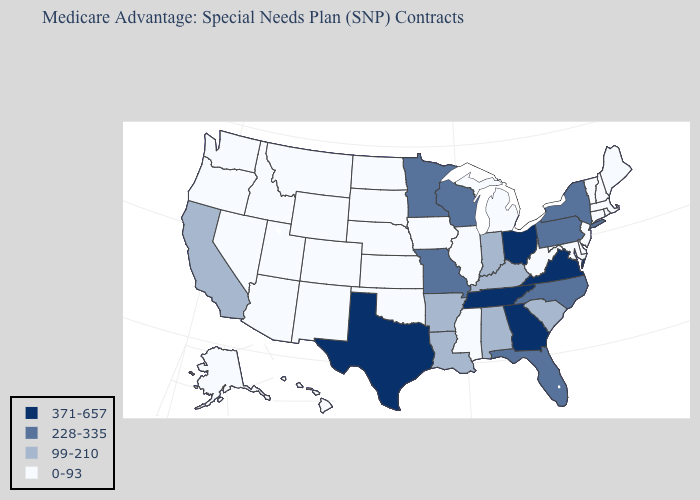Name the states that have a value in the range 0-93?
Write a very short answer. Alaska, Arizona, Colorado, Connecticut, Delaware, Hawaii, Iowa, Idaho, Illinois, Kansas, Massachusetts, Maryland, Maine, Michigan, Mississippi, Montana, North Dakota, Nebraska, New Hampshire, New Jersey, New Mexico, Nevada, Oklahoma, Oregon, Rhode Island, South Dakota, Utah, Vermont, Washington, West Virginia, Wyoming. Name the states that have a value in the range 0-93?
Write a very short answer. Alaska, Arizona, Colorado, Connecticut, Delaware, Hawaii, Iowa, Idaho, Illinois, Kansas, Massachusetts, Maryland, Maine, Michigan, Mississippi, Montana, North Dakota, Nebraska, New Hampshire, New Jersey, New Mexico, Nevada, Oklahoma, Oregon, Rhode Island, South Dakota, Utah, Vermont, Washington, West Virginia, Wyoming. What is the lowest value in the USA?
Concise answer only. 0-93. Which states have the highest value in the USA?
Short answer required. Georgia, Ohio, Tennessee, Texas, Virginia. Does Hawaii have the same value as Massachusetts?
Short answer required. Yes. Does the map have missing data?
Short answer required. No. Does Ohio have the highest value in the MidWest?
Give a very brief answer. Yes. Name the states that have a value in the range 228-335?
Give a very brief answer. Florida, Minnesota, Missouri, North Carolina, New York, Pennsylvania, Wisconsin. Name the states that have a value in the range 371-657?
Write a very short answer. Georgia, Ohio, Tennessee, Texas, Virginia. Does Maine have a lower value than Indiana?
Give a very brief answer. Yes. What is the value of Maine?
Keep it brief. 0-93. Name the states that have a value in the range 371-657?
Write a very short answer. Georgia, Ohio, Tennessee, Texas, Virginia. Does the first symbol in the legend represent the smallest category?
Answer briefly. No. What is the value of Washington?
Be succinct. 0-93. Does the first symbol in the legend represent the smallest category?
Give a very brief answer. No. 